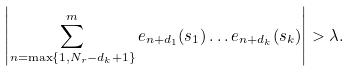<formula> <loc_0><loc_0><loc_500><loc_500>\left | \sum _ { n = \max \{ 1 , N _ { r } - d _ { k } + 1 \} } ^ { m } e _ { n + d _ { 1 } } ( s _ { 1 } ) \dots e _ { n + d _ { k } } ( s _ { k } ) \right | > \lambda .</formula> 